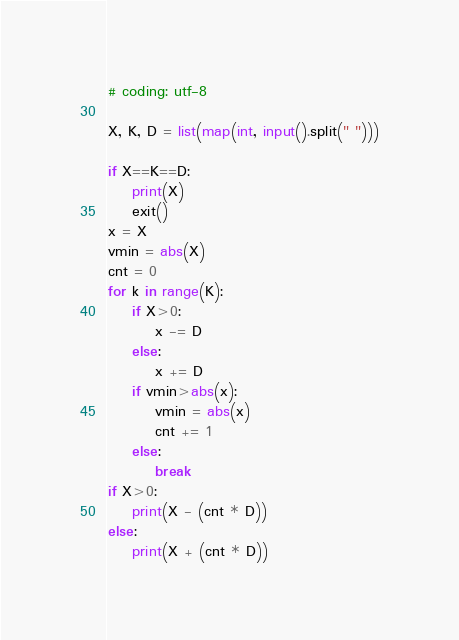<code> <loc_0><loc_0><loc_500><loc_500><_Python_># coding: utf-8

X, K, D = list(map(int, input().split(" ")))

if X==K==D:
    print(X)
    exit()
x = X
vmin = abs(X)
cnt = 0
for k in range(K):
    if X>0:
        x -= D
    else:
        x += D
    if vmin>abs(x):
        vmin = abs(x)
        cnt += 1
    else:
        break
if X>0:
    print(X - (cnt * D))
else:
    print(X + (cnt * D))</code> 